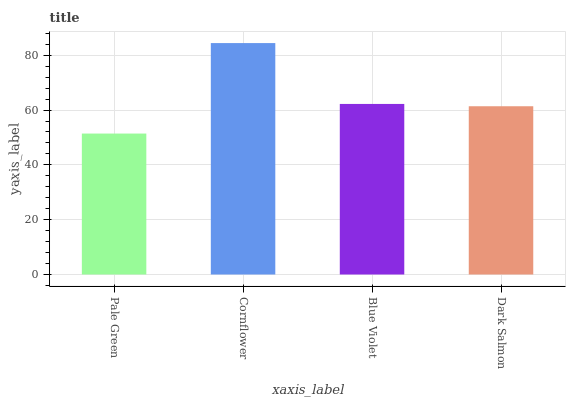Is Pale Green the minimum?
Answer yes or no. Yes. Is Cornflower the maximum?
Answer yes or no. Yes. Is Blue Violet the minimum?
Answer yes or no. No. Is Blue Violet the maximum?
Answer yes or no. No. Is Cornflower greater than Blue Violet?
Answer yes or no. Yes. Is Blue Violet less than Cornflower?
Answer yes or no. Yes. Is Blue Violet greater than Cornflower?
Answer yes or no. No. Is Cornflower less than Blue Violet?
Answer yes or no. No. Is Blue Violet the high median?
Answer yes or no. Yes. Is Dark Salmon the low median?
Answer yes or no. Yes. Is Pale Green the high median?
Answer yes or no. No. Is Pale Green the low median?
Answer yes or no. No. 